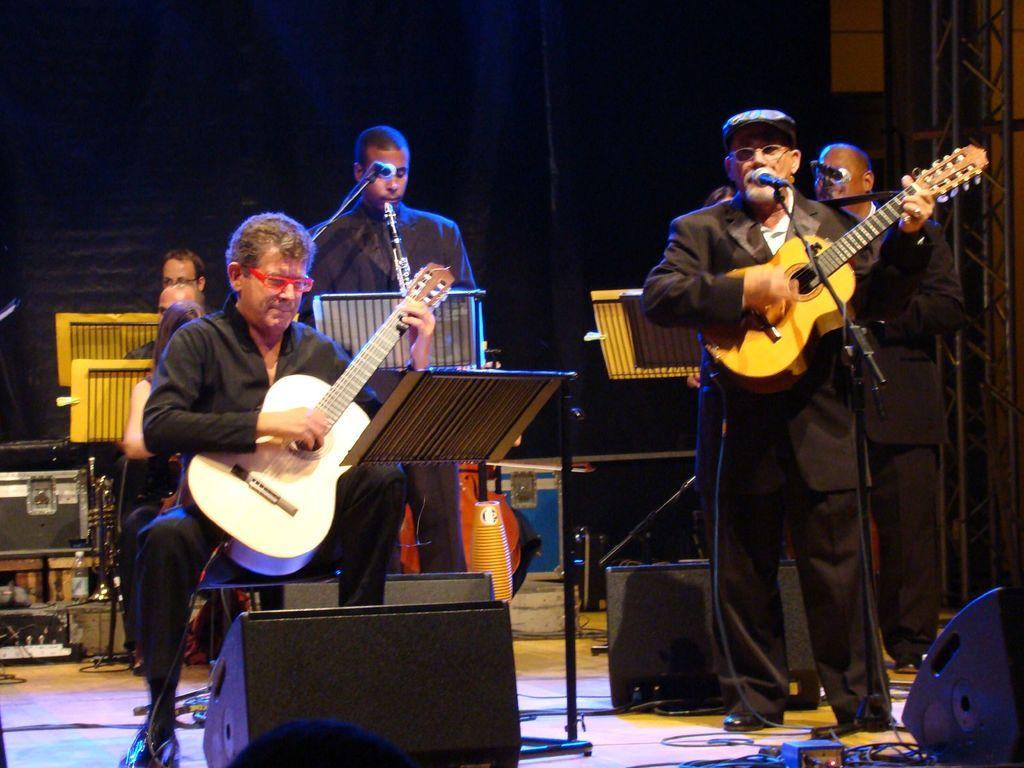Describe this image in one or two sentences. This is a picture stage, there are group of people of a people holding the music instrument. The man in black blazer holding a guitar in front of the man there is a microphone with stand. Background of these people is a wall. 